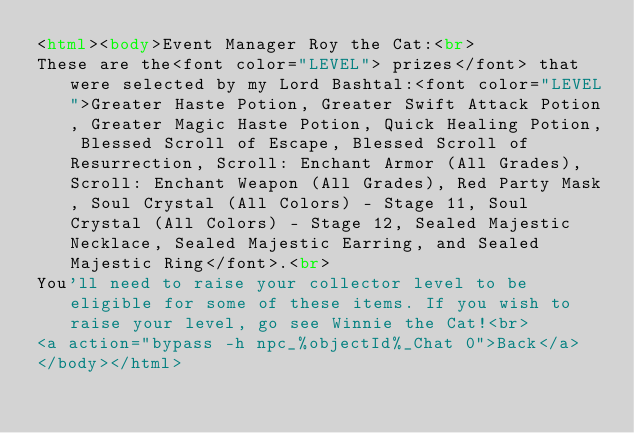Convert code to text. <code><loc_0><loc_0><loc_500><loc_500><_HTML_><html><body>Event Manager Roy the Cat:<br>
These are the<font color="LEVEL"> prizes</font> that were selected by my Lord Bashtal:<font color="LEVEL">Greater Haste Potion, Greater Swift Attack Potion, Greater Magic Haste Potion, Quick Healing Potion, Blessed Scroll of Escape, Blessed Scroll of Resurrection, Scroll: Enchant Armor (All Grades), Scroll: Enchant Weapon (All Grades), Red Party Mask, Soul Crystal (All Colors) - Stage 11, Soul Crystal (All Colors) - Stage 12, Sealed Majestic Necklace, Sealed Majestic Earring, and Sealed Majestic Ring</font>.<br>
You'll need to raise your collector level to be eligible for some of these items. If you wish to raise your level, go see Winnie the Cat!<br>
<a action="bypass -h npc_%objectId%_Chat 0">Back</a>
</body></html>
</code> 